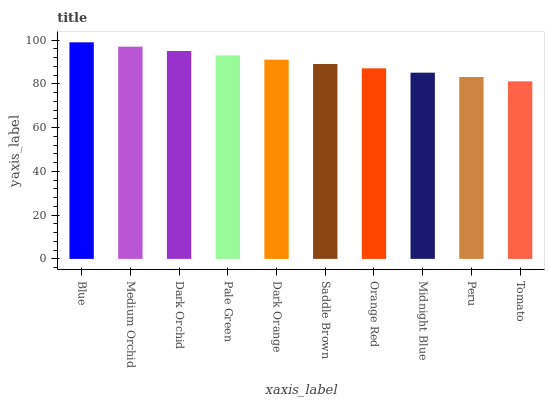Is Tomato the minimum?
Answer yes or no. Yes. Is Blue the maximum?
Answer yes or no. Yes. Is Medium Orchid the minimum?
Answer yes or no. No. Is Medium Orchid the maximum?
Answer yes or no. No. Is Blue greater than Medium Orchid?
Answer yes or no. Yes. Is Medium Orchid less than Blue?
Answer yes or no. Yes. Is Medium Orchid greater than Blue?
Answer yes or no. No. Is Blue less than Medium Orchid?
Answer yes or no. No. Is Dark Orange the high median?
Answer yes or no. Yes. Is Saddle Brown the low median?
Answer yes or no. Yes. Is Midnight Blue the high median?
Answer yes or no. No. Is Dark Orange the low median?
Answer yes or no. No. 